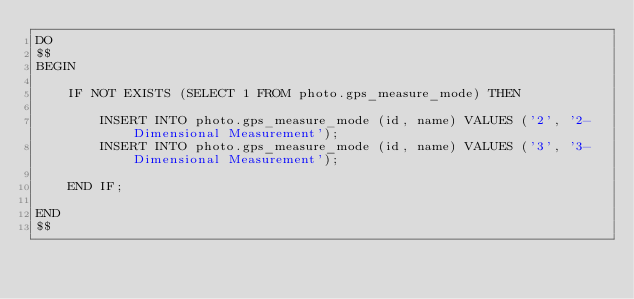<code> <loc_0><loc_0><loc_500><loc_500><_SQL_>DO
$$
BEGIN

    IF NOT EXISTS (SELECT 1 FROM photo.gps_measure_mode) THEN
        
        INSERT INTO photo.gps_measure_mode (id, name) VALUES ('2', '2-Dimensional Measurement');
        INSERT INTO photo.gps_measure_mode (id, name) VALUES ('3', '3-Dimensional Measurement');

    END IF;

END
$$
</code> 